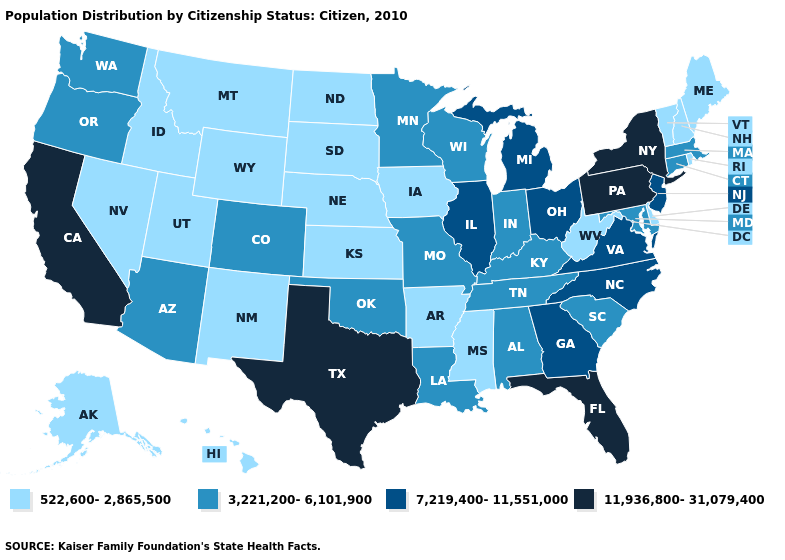What is the highest value in the Northeast ?
Keep it brief. 11,936,800-31,079,400. What is the lowest value in states that border Tennessee?
Keep it brief. 522,600-2,865,500. Does the first symbol in the legend represent the smallest category?
Short answer required. Yes. Does the first symbol in the legend represent the smallest category?
Quick response, please. Yes. Does Missouri have the highest value in the USA?
Short answer required. No. Among the states that border Wyoming , does Idaho have the lowest value?
Quick response, please. Yes. Which states have the lowest value in the USA?
Answer briefly. Alaska, Arkansas, Delaware, Hawaii, Idaho, Iowa, Kansas, Maine, Mississippi, Montana, Nebraska, Nevada, New Hampshire, New Mexico, North Dakota, Rhode Island, South Dakota, Utah, Vermont, West Virginia, Wyoming. What is the value of California?
Write a very short answer. 11,936,800-31,079,400. Does California have the highest value in the West?
Be succinct. Yes. What is the value of New Jersey?
Concise answer only. 7,219,400-11,551,000. Does Nebraska have the lowest value in the USA?
Short answer required. Yes. Among the states that border Louisiana , does Texas have the highest value?
Give a very brief answer. Yes. Name the states that have a value in the range 3,221,200-6,101,900?
Keep it brief. Alabama, Arizona, Colorado, Connecticut, Indiana, Kentucky, Louisiana, Maryland, Massachusetts, Minnesota, Missouri, Oklahoma, Oregon, South Carolina, Tennessee, Washington, Wisconsin. Among the states that border Minnesota , which have the highest value?
Write a very short answer. Wisconsin. Name the states that have a value in the range 11,936,800-31,079,400?
Write a very short answer. California, Florida, New York, Pennsylvania, Texas. 